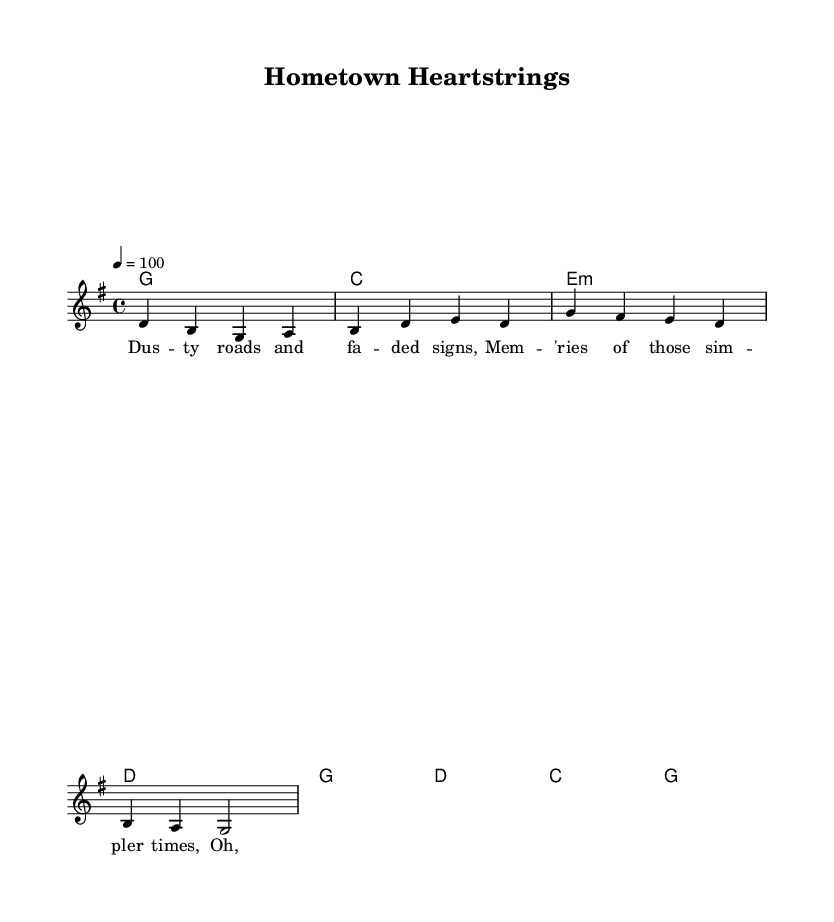What is the key signature of this music? The key signature is G major, indicated by one sharp on the F line, which corresponds to the notes that can be played in the piece.
Answer: G major What is the time signature of this music? The time signature is 4/4, shown at the beginning of the score, which indicates four beats per measure and that the quarter note receives one beat.
Answer: 4/4 What is the tempo marking for this piece? The tempo marking indicates a speed of 100 beats per minute, denoted as "4 = 100", which directs the performers on how fast to play the piece.
Answer: 100 How many measures are in the verse section? The verse section consists of two measures, as indicated by the grouping of notes and chords specifically labeled for that section.
Answer: 2 What are the first two words of the chorus? The chorus begins with "Oh, home", as indicated by the lyrics written under the corresponding melody notes in the music sheet.
Answer: Oh, home Which chord follows the G major chord in the verse? The chord following the G major chord in the verse is C major, as shown in the chord progression laid out for that section of the music.
Answer: C major What theme does the song focus on? The lyrics indicate that the theme focuses on nostalgia for small-town roots and community support, reflecting the sentiments expressed in the lyrics and overall vibe of country rock music.
Answer: Nostalgia 